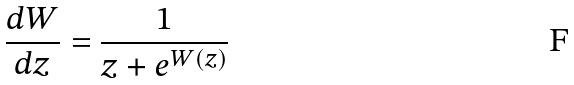<formula> <loc_0><loc_0><loc_500><loc_500>\frac { d W } { d z } = \frac { 1 } { z + e ^ { W ( z ) } }</formula> 